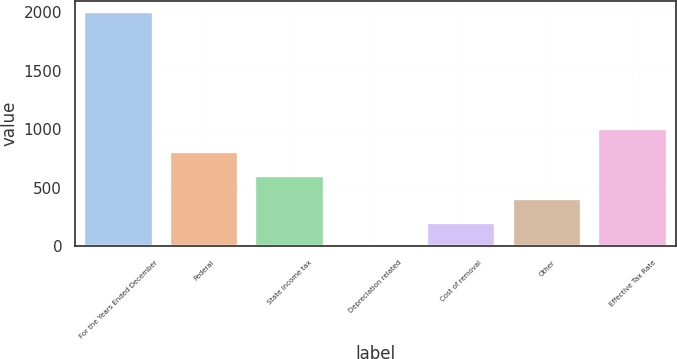<chart> <loc_0><loc_0><loc_500><loc_500><bar_chart><fcel>For the Years Ended December<fcel>Federal<fcel>State income tax<fcel>Depreciation related<fcel>Cost of removal<fcel>Other<fcel>Effective Tax Rate<nl><fcel>2001<fcel>802.2<fcel>602.4<fcel>3<fcel>202.8<fcel>402.6<fcel>1002<nl></chart> 